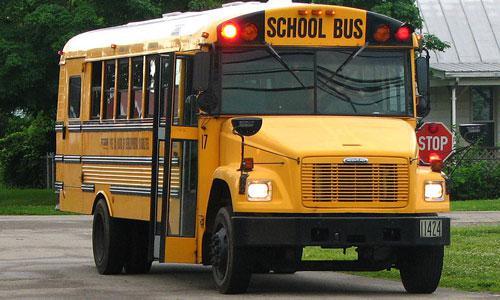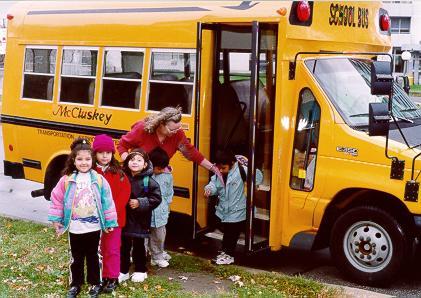The first image is the image on the left, the second image is the image on the right. Assess this claim about the two images: "At least one bus' doors are open.". Correct or not? Answer yes or no. Yes. The first image is the image on the left, the second image is the image on the right. Given the left and right images, does the statement "The two school buses are facing nearly opposite directions." hold true? Answer yes or no. No. 